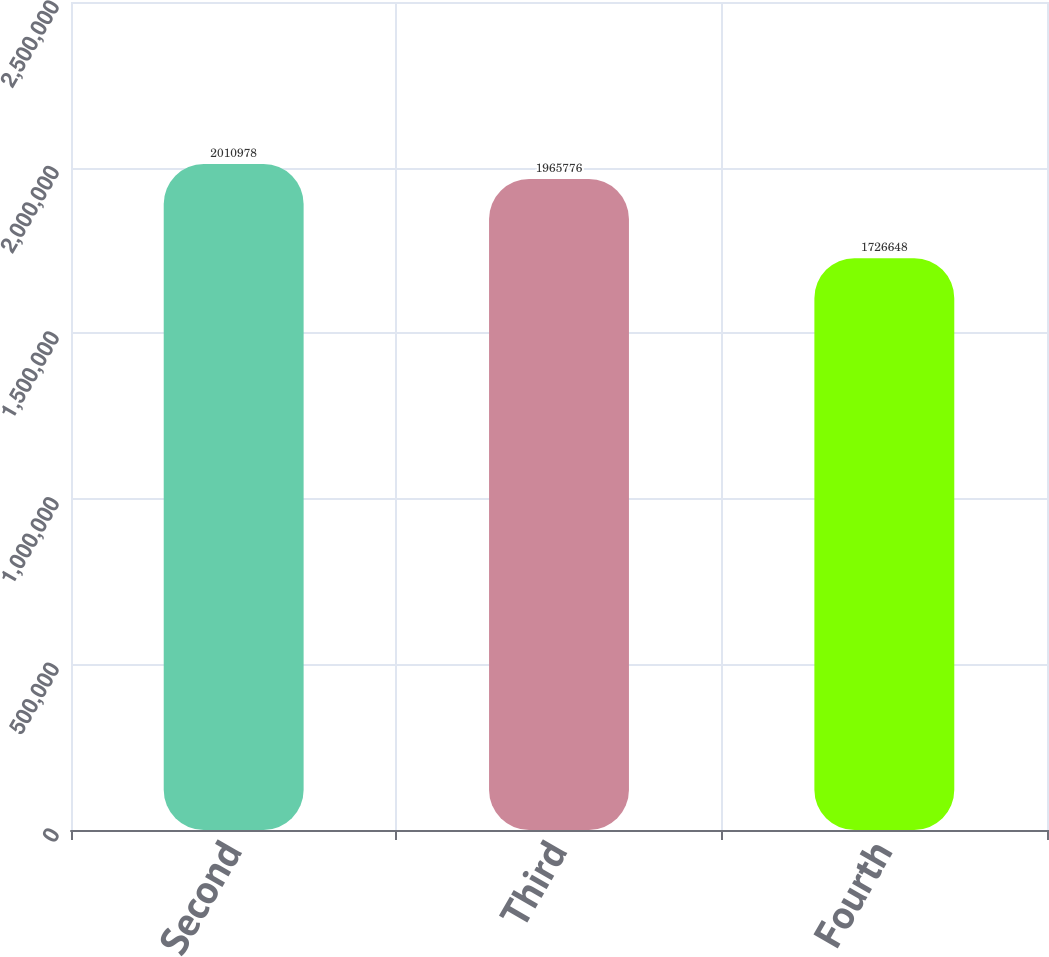Convert chart to OTSL. <chart><loc_0><loc_0><loc_500><loc_500><bar_chart><fcel>Second<fcel>Third<fcel>Fourth<nl><fcel>2.01098e+06<fcel>1.96578e+06<fcel>1.72665e+06<nl></chart> 